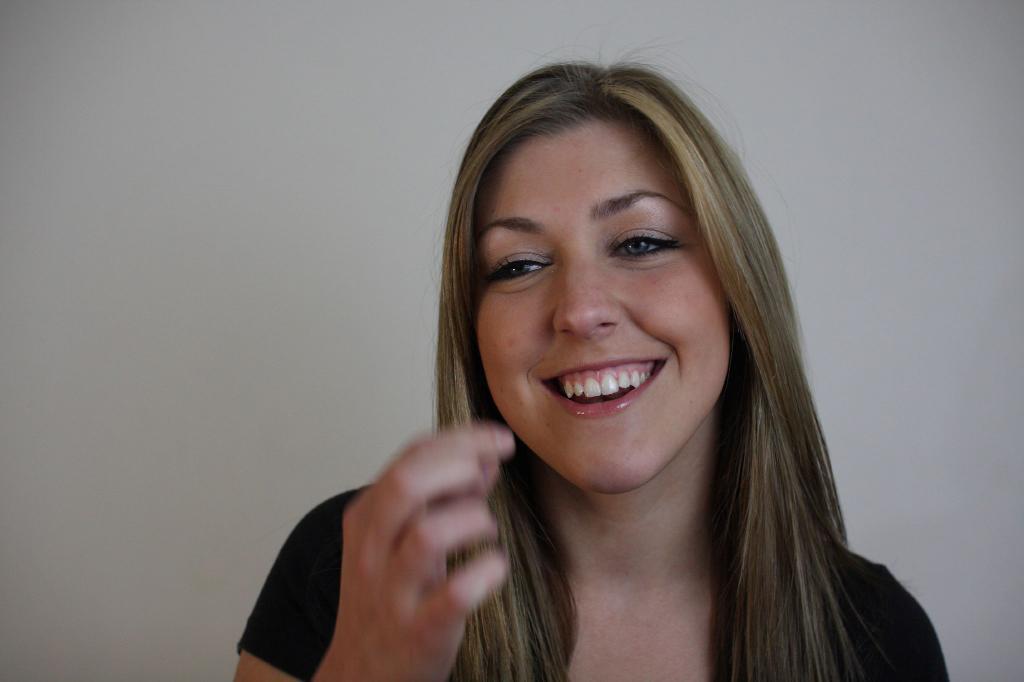Could you give a brief overview of what you see in this image? In this image there is a woman smiling. 